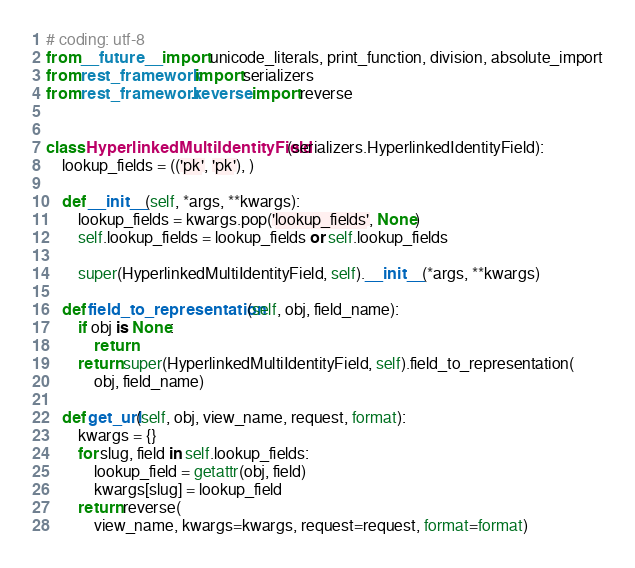<code> <loc_0><loc_0><loc_500><loc_500><_Python_># coding: utf-8
from __future__ import unicode_literals, print_function, division, absolute_import
from rest_framework import serializers
from rest_framework.reverse import reverse


class HyperlinkedMultiIdentityField(serializers.HyperlinkedIdentityField):
    lookup_fields = (('pk', 'pk'), )

    def __init__(self, *args, **kwargs):
        lookup_fields = kwargs.pop('lookup_fields', None)
        self.lookup_fields = lookup_fields or self.lookup_fields

        super(HyperlinkedMultiIdentityField, self).__init__(*args, **kwargs)

    def field_to_representation(self, obj, field_name):
        if obj is None:
            return
        return super(HyperlinkedMultiIdentityField, self).field_to_representation(
            obj, field_name)

    def get_url(self, obj, view_name, request, format):
        kwargs = {}
        for slug, field in self.lookup_fields:
            lookup_field = getattr(obj, field)
            kwargs[slug] = lookup_field
        return reverse(
            view_name, kwargs=kwargs, request=request, format=format)
</code> 